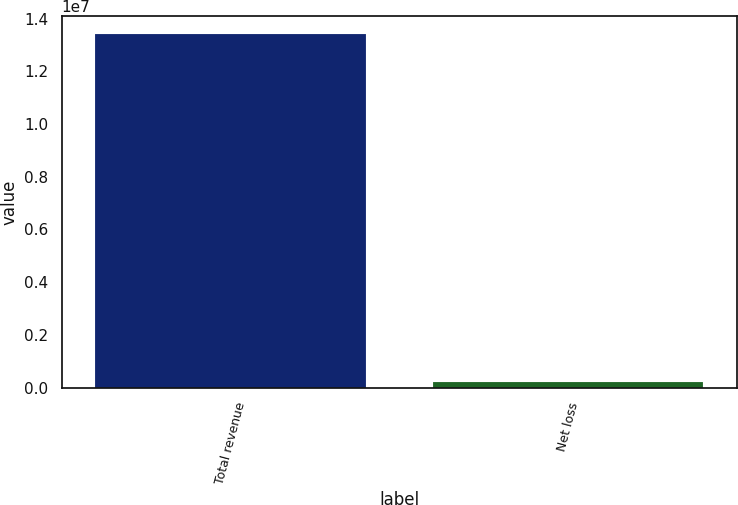<chart> <loc_0><loc_0><loc_500><loc_500><bar_chart><fcel>Total revenue<fcel>Net loss<nl><fcel>1.3423e+07<fcel>224000<nl></chart> 